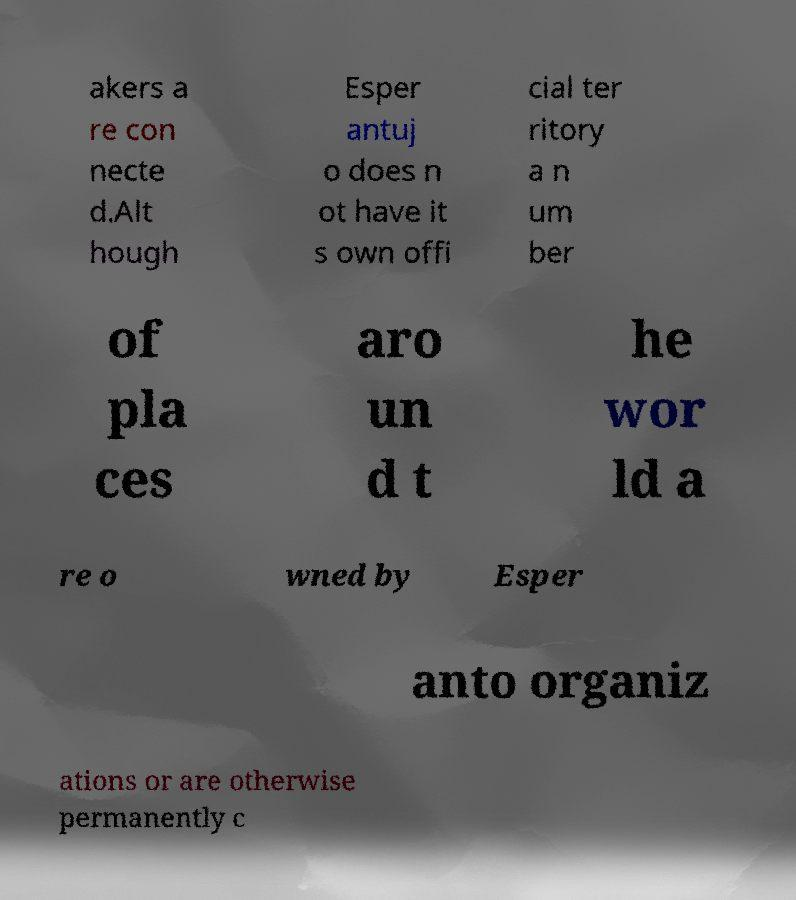Can you accurately transcribe the text from the provided image for me? akers a re con necte d.Alt hough Esper antuj o does n ot have it s own offi cial ter ritory a n um ber of pla ces aro un d t he wor ld a re o wned by Esper anto organiz ations or are otherwise permanently c 